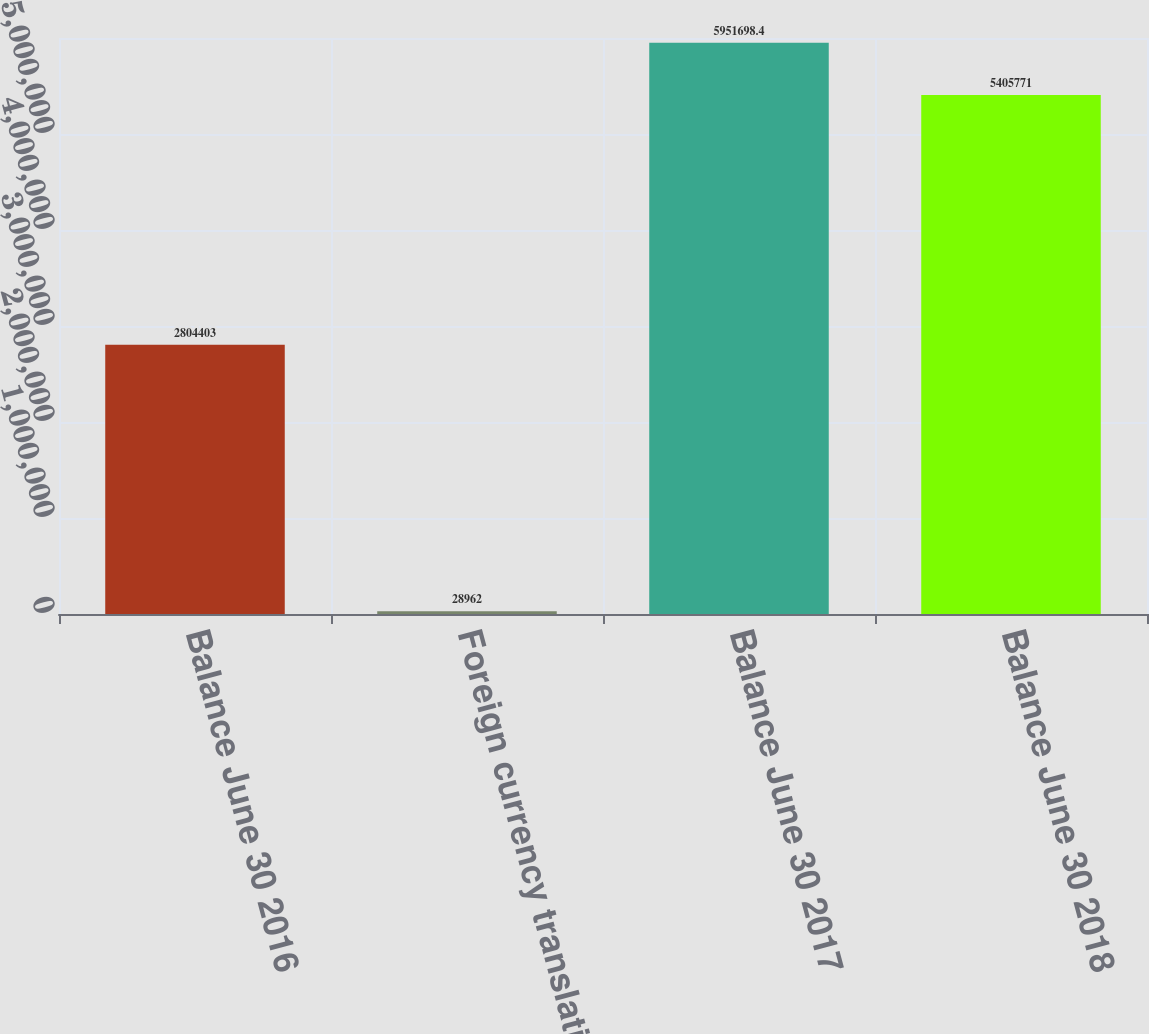Convert chart. <chart><loc_0><loc_0><loc_500><loc_500><bar_chart><fcel>Balance June 30 2016<fcel>Foreign currency translation<fcel>Balance June 30 2017<fcel>Balance June 30 2018<nl><fcel>2.8044e+06<fcel>28962<fcel>5.9517e+06<fcel>5.40577e+06<nl></chart> 